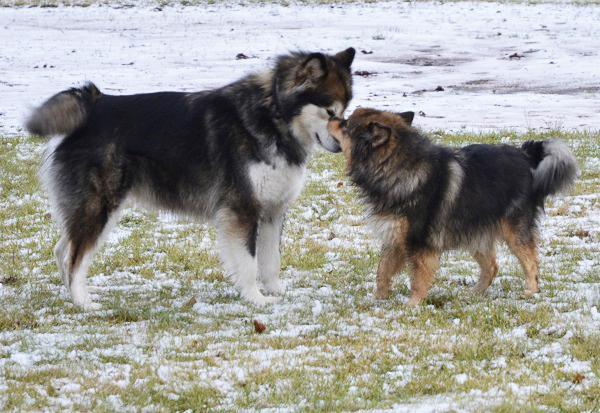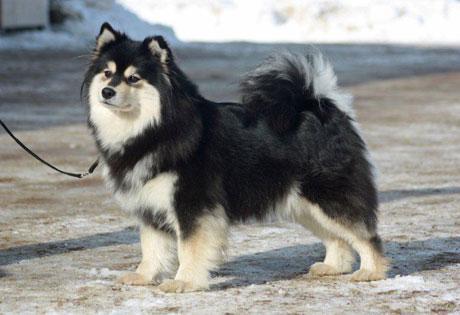The first image is the image on the left, the second image is the image on the right. For the images shown, is this caption "The left image contains exactly one dog." true? Answer yes or no. No. 